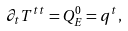<formula> <loc_0><loc_0><loc_500><loc_500>\partial _ { t } T ^ { t t } = Q ^ { 0 } _ { E } = q ^ { t } ,</formula> 